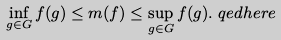<formula> <loc_0><loc_0><loc_500><loc_500>\inf _ { g \in G } f ( g ) & \leq m ( f ) \leq \sup _ { g \in G } f ( g ) . \ q e d h e r e</formula> 